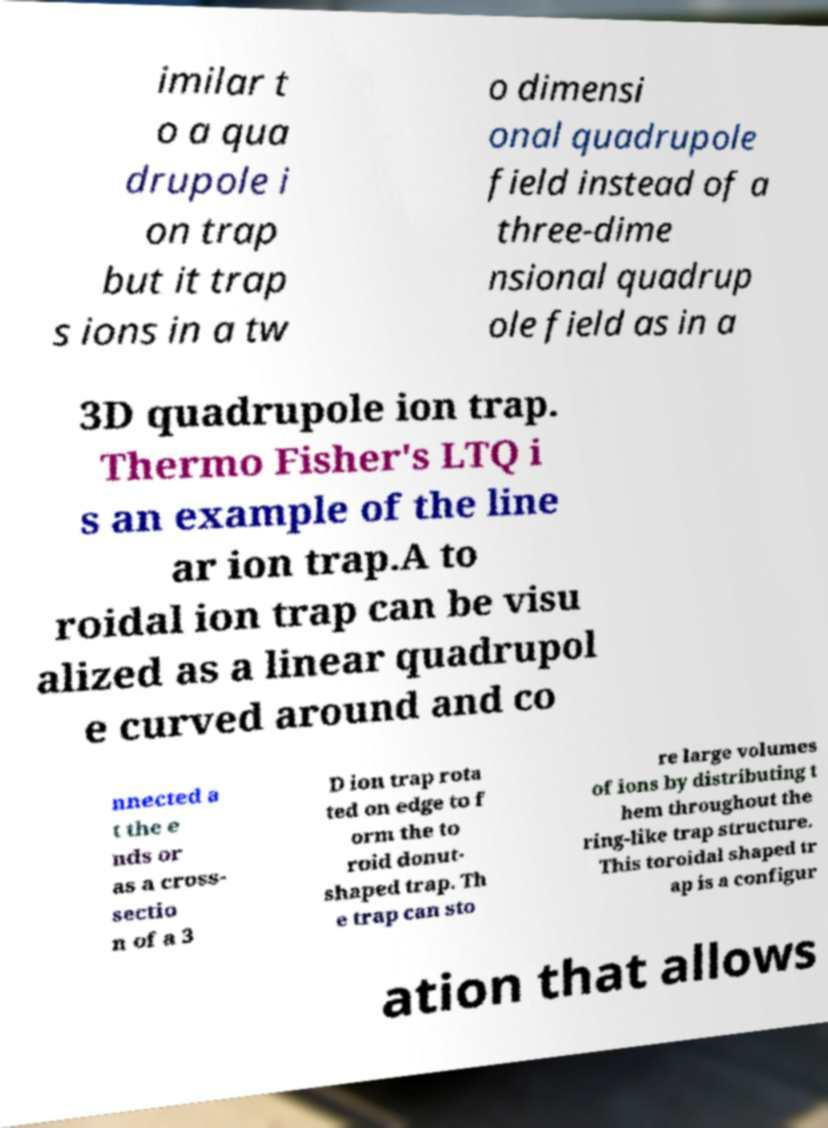I need the written content from this picture converted into text. Can you do that? imilar t o a qua drupole i on trap but it trap s ions in a tw o dimensi onal quadrupole field instead of a three-dime nsional quadrup ole field as in a 3D quadrupole ion trap. Thermo Fisher's LTQ i s an example of the line ar ion trap.A to roidal ion trap can be visu alized as a linear quadrupol e curved around and co nnected a t the e nds or as a cross- sectio n of a 3 D ion trap rota ted on edge to f orm the to roid donut- shaped trap. Th e trap can sto re large volumes of ions by distributing t hem throughout the ring-like trap structure. This toroidal shaped tr ap is a configur ation that allows 